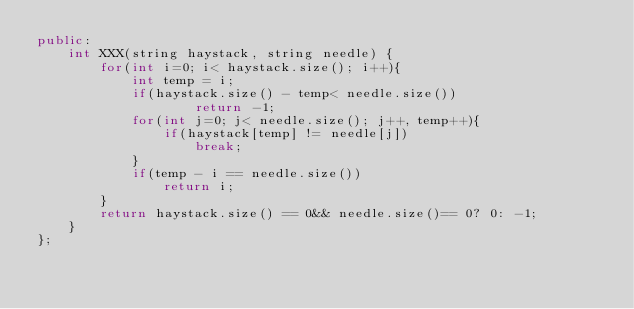<code> <loc_0><loc_0><loc_500><loc_500><_C++_>public:
    int XXX(string haystack, string needle) {
        for(int i=0; i< haystack.size(); i++){
            int temp = i;
            if(haystack.size() - temp< needle.size())
                    return -1;
            for(int j=0; j< needle.size(); j++, temp++){
                if(haystack[temp] != needle[j])
                    break;
            }
            if(temp - i == needle.size())
                return i;
        }
        return haystack.size() == 0&& needle.size()== 0? 0: -1;
    }
};

</code> 